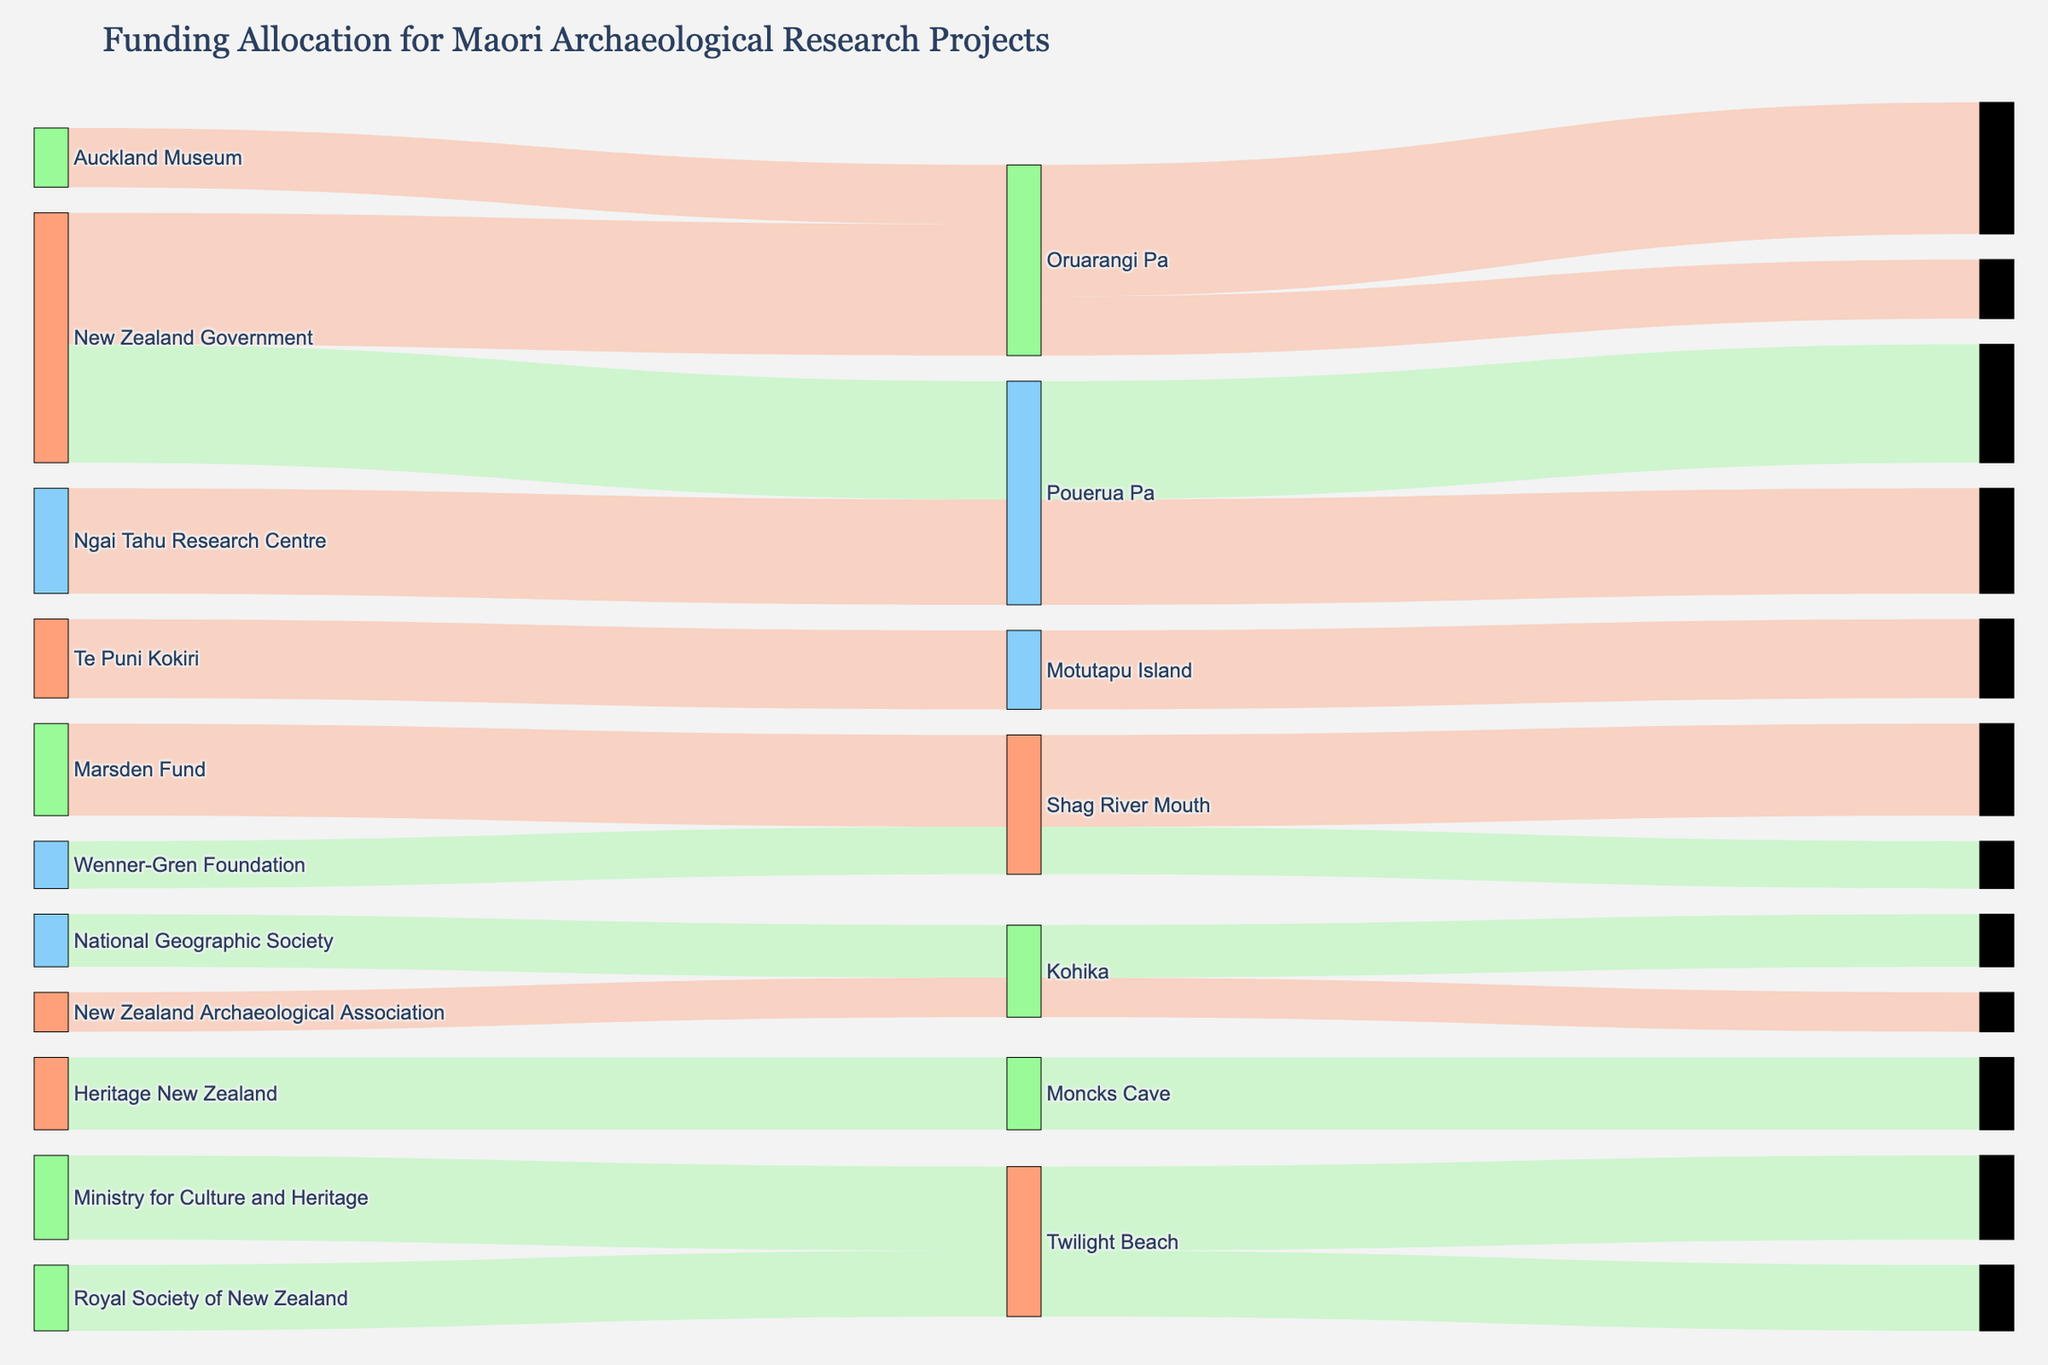What is the title of the plot? The title is located at the top of the figure, usually, in larger and bolder font compared to other text elements. It helps the viewer understand what the figure represents.
Answer: Funding Allocation for Maori Archaeological Research Projects How much funding was allocated to the Wairau Bar site? To find the amount of funding allocated to the Wairau Bar site, look at the ending labels and follow the flow from this site back to the amount value.
Answer: $500,000 Which source provided the highest amount of funding? To determine the source with the highest funding, compare the values associated with each source label. Find the source label with the highest total flow value.
Answer: New Zealand Government Which institution received the most diversified funding (most different sources)? To determine this, count the number of distinct source flows entering each institution. The institution with the most distinct incoming flows is the one with the most diversified funding.
Answer: University of Otago Which site received funding from the Wenner-Gren Foundation? Identify the label for the Wenner-Gren Foundation, then follow the flow from this source to the site label.
Answer: Twilight Beach What is the total amount of funding received by the University of Canterbury? Add the amounts of all flows directed to the University of Canterbury, following the links from the source to the institution.
Answer: $350,000 Does the University of Auckland receive more funding compared to the University of Otago? Compare the total amount of funding flowing into the University of Auckland to that flowing into the University of Otago.
Answer: No How many different institutions received funding? Count the number of unique institution labels present in the middle section of the Sankey diagram.
Answer: 8 Is the funding from Marsden Fund directed to multiple sites? Follow the flow from the Marsden Fund source and see if it splits into multiple site labels.
Answer: No, it's directed to one site, Palliser Bay 